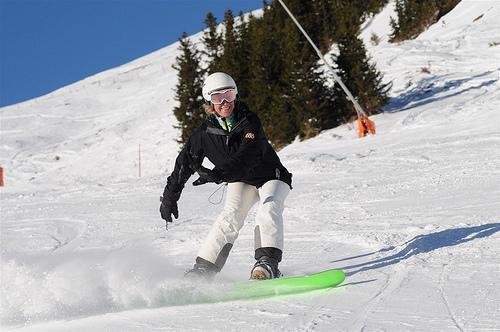How many people are in this scene?
Give a very brief answer. 1. 